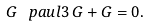Convert formula to latex. <formula><loc_0><loc_0><loc_500><loc_500>G \, \ p a u l { 3 } \, G + G = 0 .</formula> 